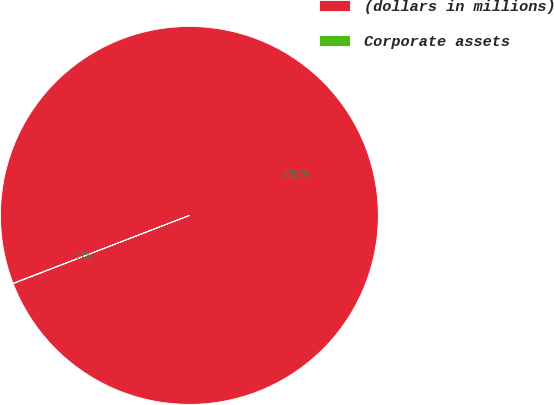<chart> <loc_0><loc_0><loc_500><loc_500><pie_chart><fcel>(dollars in millions)<fcel>Corporate assets<nl><fcel>99.97%<fcel>0.03%<nl></chart> 